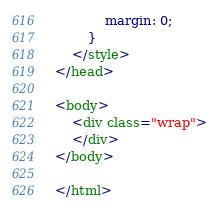Convert code to text. <code><loc_0><loc_0><loc_500><loc_500><_HTML_>            margin: 0;
        }
    </style>
</head>

<body>
    <div class="wrap">
    </div>
</body>

</html></code> 